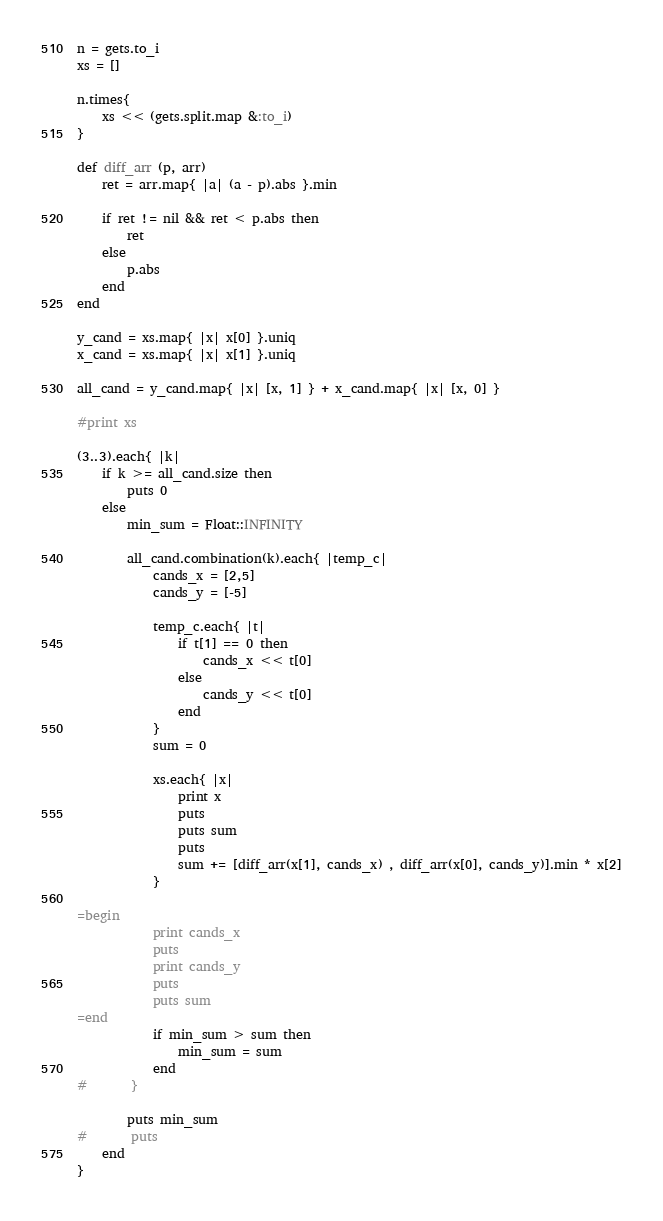Convert code to text. <code><loc_0><loc_0><loc_500><loc_500><_Ruby_>n = gets.to_i
xs = []

n.times{
	xs << (gets.split.map &:to_i)
}

def diff_arr (p, arr)
	ret = arr.map{ |a| (a - p).abs }.min
	
	if ret != nil && ret < p.abs then
		ret
	else
		p.abs
	end
end

y_cand = xs.map{ |x| x[0] }.uniq
x_cand = xs.map{ |x| x[1] }.uniq

all_cand = y_cand.map{ |x| [x, 1] } + x_cand.map{ |x| [x, 0] }

#print xs

(3..3).each{ |k|
	if k >= all_cand.size then
		puts 0
	else
		min_sum = Float::INFINITY
	
		all_cand.combination(k).each{ |temp_c|
			cands_x = [2,5]
			cands_y = [-5]

			temp_c.each{ |t|
				if t[1] == 0 then
					cands_x << t[0]
				else
					cands_y << t[0]
				end
			}
			sum = 0

			xs.each{ |x|
				print x
				puts
				puts sum
				puts
				sum += [diff_arr(x[1], cands_x) , diff_arr(x[0], cands_y)].min * x[2]
			}
			
=begin
			print cands_x
			puts
			print cands_y
			puts
			puts sum
=end			
			if min_sum > sum then
				min_sum = sum
			end
#		}
		
		puts min_sum
#		puts
	end
}

</code> 